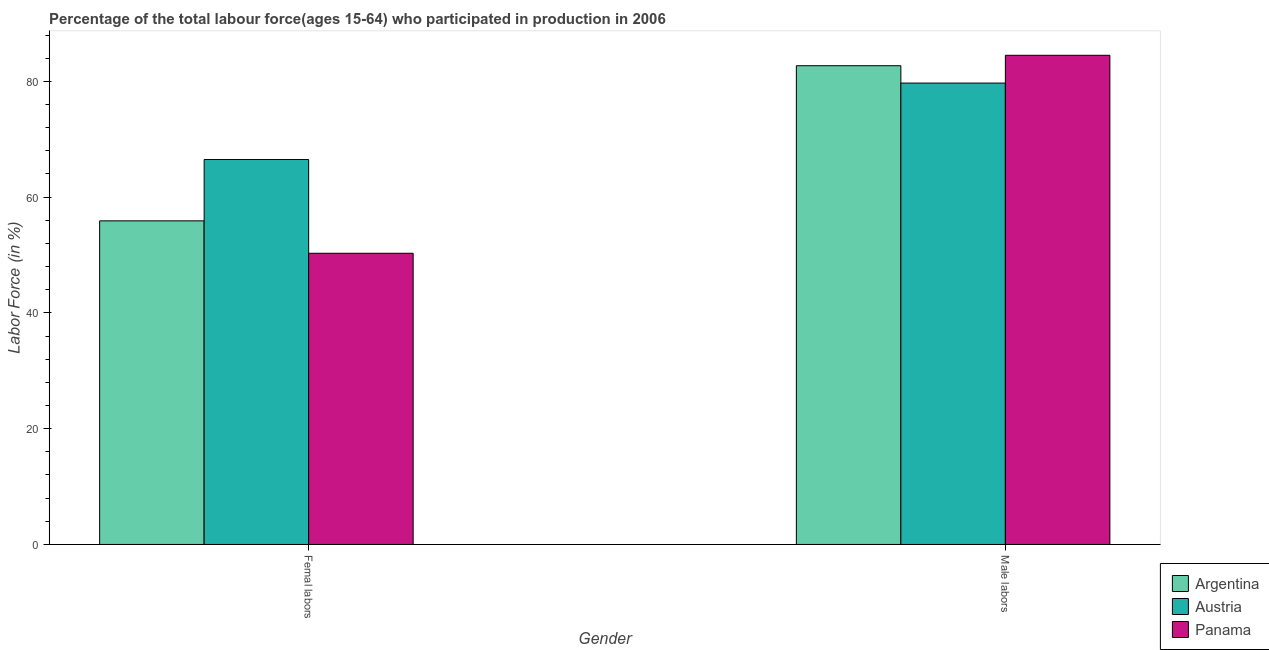Are the number of bars per tick equal to the number of legend labels?
Keep it short and to the point. Yes. Are the number of bars on each tick of the X-axis equal?
Provide a short and direct response. Yes. What is the label of the 2nd group of bars from the left?
Give a very brief answer. Male labors. What is the percentage of female labor force in Argentina?
Offer a terse response. 55.9. Across all countries, what is the maximum percentage of male labour force?
Make the answer very short. 84.5. Across all countries, what is the minimum percentage of male labour force?
Your answer should be compact. 79.7. In which country was the percentage of female labor force minimum?
Ensure brevity in your answer.  Panama. What is the total percentage of female labor force in the graph?
Ensure brevity in your answer.  172.7. What is the difference between the percentage of male labour force in Austria and that in Panama?
Your response must be concise. -4.8. What is the difference between the percentage of male labour force in Panama and the percentage of female labor force in Argentina?
Offer a terse response. 28.6. What is the average percentage of female labor force per country?
Provide a short and direct response. 57.57. What is the difference between the percentage of male labour force and percentage of female labor force in Panama?
Make the answer very short. 34.2. What is the ratio of the percentage of male labour force in Panama to that in Argentina?
Offer a terse response. 1.02. What does the 2nd bar from the left in Femal labors represents?
Your answer should be compact. Austria. How many bars are there?
Offer a terse response. 6. Are the values on the major ticks of Y-axis written in scientific E-notation?
Your answer should be very brief. No. Does the graph contain grids?
Your response must be concise. No. How many legend labels are there?
Provide a short and direct response. 3. How are the legend labels stacked?
Give a very brief answer. Vertical. What is the title of the graph?
Keep it short and to the point. Percentage of the total labour force(ages 15-64) who participated in production in 2006. Does "Costa Rica" appear as one of the legend labels in the graph?
Provide a short and direct response. No. What is the label or title of the Y-axis?
Your response must be concise. Labor Force (in %). What is the Labor Force (in %) in Argentina in Femal labors?
Your answer should be very brief. 55.9. What is the Labor Force (in %) of Austria in Femal labors?
Provide a short and direct response. 66.5. What is the Labor Force (in %) in Panama in Femal labors?
Ensure brevity in your answer.  50.3. What is the Labor Force (in %) of Argentina in Male labors?
Give a very brief answer. 82.7. What is the Labor Force (in %) of Austria in Male labors?
Ensure brevity in your answer.  79.7. What is the Labor Force (in %) in Panama in Male labors?
Offer a very short reply. 84.5. Across all Gender, what is the maximum Labor Force (in %) of Argentina?
Offer a terse response. 82.7. Across all Gender, what is the maximum Labor Force (in %) of Austria?
Your answer should be very brief. 79.7. Across all Gender, what is the maximum Labor Force (in %) of Panama?
Your answer should be compact. 84.5. Across all Gender, what is the minimum Labor Force (in %) of Argentina?
Ensure brevity in your answer.  55.9. Across all Gender, what is the minimum Labor Force (in %) in Austria?
Your answer should be very brief. 66.5. Across all Gender, what is the minimum Labor Force (in %) of Panama?
Your response must be concise. 50.3. What is the total Labor Force (in %) in Argentina in the graph?
Give a very brief answer. 138.6. What is the total Labor Force (in %) in Austria in the graph?
Offer a very short reply. 146.2. What is the total Labor Force (in %) of Panama in the graph?
Provide a succinct answer. 134.8. What is the difference between the Labor Force (in %) in Argentina in Femal labors and that in Male labors?
Your response must be concise. -26.8. What is the difference between the Labor Force (in %) in Panama in Femal labors and that in Male labors?
Give a very brief answer. -34.2. What is the difference between the Labor Force (in %) of Argentina in Femal labors and the Labor Force (in %) of Austria in Male labors?
Keep it short and to the point. -23.8. What is the difference between the Labor Force (in %) of Argentina in Femal labors and the Labor Force (in %) of Panama in Male labors?
Your answer should be compact. -28.6. What is the average Labor Force (in %) of Argentina per Gender?
Give a very brief answer. 69.3. What is the average Labor Force (in %) in Austria per Gender?
Keep it short and to the point. 73.1. What is the average Labor Force (in %) in Panama per Gender?
Your answer should be very brief. 67.4. What is the difference between the Labor Force (in %) of Argentina and Labor Force (in %) of Panama in Femal labors?
Offer a terse response. 5.6. What is the difference between the Labor Force (in %) in Austria and Labor Force (in %) in Panama in Femal labors?
Give a very brief answer. 16.2. What is the ratio of the Labor Force (in %) of Argentina in Femal labors to that in Male labors?
Offer a very short reply. 0.68. What is the ratio of the Labor Force (in %) of Austria in Femal labors to that in Male labors?
Give a very brief answer. 0.83. What is the ratio of the Labor Force (in %) in Panama in Femal labors to that in Male labors?
Keep it short and to the point. 0.6. What is the difference between the highest and the second highest Labor Force (in %) in Argentina?
Offer a very short reply. 26.8. What is the difference between the highest and the second highest Labor Force (in %) of Austria?
Your answer should be very brief. 13.2. What is the difference between the highest and the second highest Labor Force (in %) of Panama?
Your response must be concise. 34.2. What is the difference between the highest and the lowest Labor Force (in %) of Argentina?
Make the answer very short. 26.8. What is the difference between the highest and the lowest Labor Force (in %) of Austria?
Give a very brief answer. 13.2. What is the difference between the highest and the lowest Labor Force (in %) in Panama?
Your answer should be very brief. 34.2. 